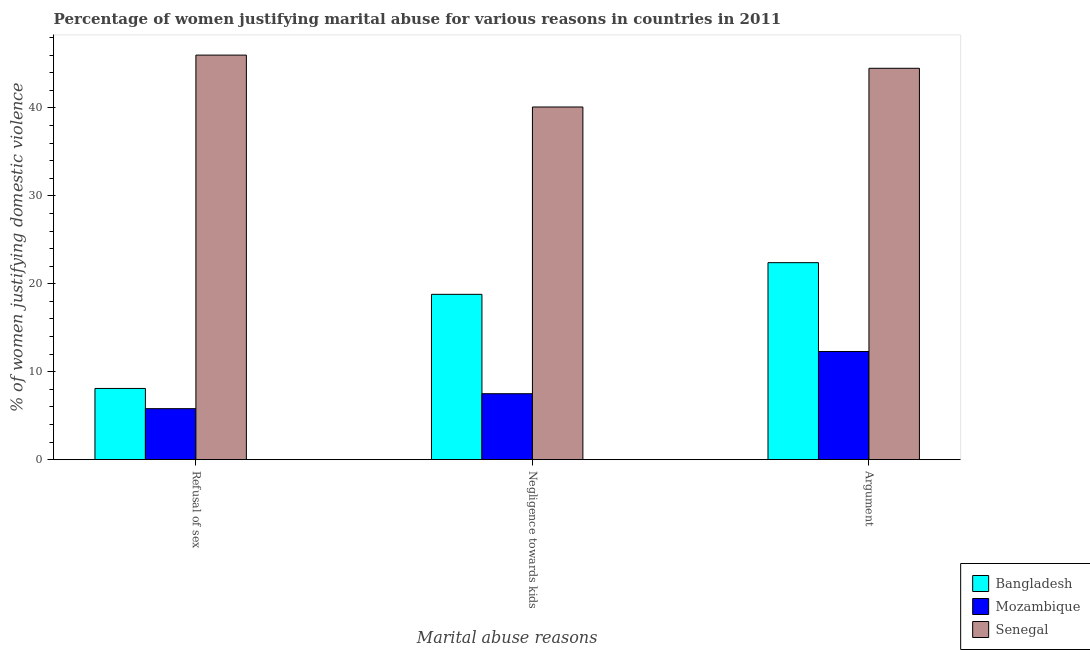How many bars are there on the 3rd tick from the left?
Ensure brevity in your answer.  3. How many bars are there on the 1st tick from the right?
Provide a succinct answer. 3. What is the label of the 1st group of bars from the left?
Offer a very short reply. Refusal of sex. Across all countries, what is the maximum percentage of women justifying domestic violence due to negligence towards kids?
Give a very brief answer. 40.1. Across all countries, what is the minimum percentage of women justifying domestic violence due to arguments?
Make the answer very short. 12.3. In which country was the percentage of women justifying domestic violence due to refusal of sex maximum?
Your response must be concise. Senegal. In which country was the percentage of women justifying domestic violence due to refusal of sex minimum?
Your answer should be very brief. Mozambique. What is the total percentage of women justifying domestic violence due to arguments in the graph?
Provide a succinct answer. 79.2. What is the difference between the percentage of women justifying domestic violence due to refusal of sex in Senegal and that in Mozambique?
Offer a very short reply. 40.2. What is the difference between the percentage of women justifying domestic violence due to refusal of sex in Bangladesh and the percentage of women justifying domestic violence due to arguments in Mozambique?
Keep it short and to the point. -4.2. What is the average percentage of women justifying domestic violence due to refusal of sex per country?
Your answer should be very brief. 19.97. What is the difference between the percentage of women justifying domestic violence due to negligence towards kids and percentage of women justifying domestic violence due to arguments in Bangladesh?
Ensure brevity in your answer.  -3.6. In how many countries, is the percentage of women justifying domestic violence due to refusal of sex greater than 14 %?
Ensure brevity in your answer.  1. What is the ratio of the percentage of women justifying domestic violence due to arguments in Senegal to that in Bangladesh?
Offer a very short reply. 1.99. What is the difference between the highest and the second highest percentage of women justifying domestic violence due to negligence towards kids?
Your response must be concise. 21.3. What is the difference between the highest and the lowest percentage of women justifying domestic violence due to arguments?
Provide a succinct answer. 32.2. What does the 3rd bar from the left in Argument represents?
Keep it short and to the point. Senegal. What does the 1st bar from the right in Negligence towards kids represents?
Provide a short and direct response. Senegal. Is it the case that in every country, the sum of the percentage of women justifying domestic violence due to refusal of sex and percentage of women justifying domestic violence due to negligence towards kids is greater than the percentage of women justifying domestic violence due to arguments?
Make the answer very short. Yes. How many bars are there?
Your answer should be very brief. 9. How many countries are there in the graph?
Provide a short and direct response. 3. What is the difference between two consecutive major ticks on the Y-axis?
Give a very brief answer. 10. Are the values on the major ticks of Y-axis written in scientific E-notation?
Keep it short and to the point. No. Does the graph contain grids?
Your response must be concise. No. What is the title of the graph?
Ensure brevity in your answer.  Percentage of women justifying marital abuse for various reasons in countries in 2011. Does "China" appear as one of the legend labels in the graph?
Make the answer very short. No. What is the label or title of the X-axis?
Provide a short and direct response. Marital abuse reasons. What is the label or title of the Y-axis?
Ensure brevity in your answer.  % of women justifying domestic violence. What is the % of women justifying domestic violence in Mozambique in Refusal of sex?
Offer a very short reply. 5.8. What is the % of women justifying domestic violence of Bangladesh in Negligence towards kids?
Your answer should be very brief. 18.8. What is the % of women justifying domestic violence in Senegal in Negligence towards kids?
Your answer should be very brief. 40.1. What is the % of women justifying domestic violence of Bangladesh in Argument?
Ensure brevity in your answer.  22.4. What is the % of women justifying domestic violence in Mozambique in Argument?
Keep it short and to the point. 12.3. What is the % of women justifying domestic violence in Senegal in Argument?
Ensure brevity in your answer.  44.5. Across all Marital abuse reasons, what is the maximum % of women justifying domestic violence of Bangladesh?
Your answer should be compact. 22.4. Across all Marital abuse reasons, what is the minimum % of women justifying domestic violence of Bangladesh?
Keep it short and to the point. 8.1. Across all Marital abuse reasons, what is the minimum % of women justifying domestic violence of Mozambique?
Give a very brief answer. 5.8. Across all Marital abuse reasons, what is the minimum % of women justifying domestic violence of Senegal?
Keep it short and to the point. 40.1. What is the total % of women justifying domestic violence of Bangladesh in the graph?
Your answer should be very brief. 49.3. What is the total % of women justifying domestic violence in Mozambique in the graph?
Your answer should be compact. 25.6. What is the total % of women justifying domestic violence in Senegal in the graph?
Make the answer very short. 130.6. What is the difference between the % of women justifying domestic violence in Bangladesh in Refusal of sex and that in Negligence towards kids?
Give a very brief answer. -10.7. What is the difference between the % of women justifying domestic violence of Mozambique in Refusal of sex and that in Negligence towards kids?
Your response must be concise. -1.7. What is the difference between the % of women justifying domestic violence in Bangladesh in Refusal of sex and that in Argument?
Ensure brevity in your answer.  -14.3. What is the difference between the % of women justifying domestic violence in Mozambique in Refusal of sex and that in Argument?
Your answer should be very brief. -6.5. What is the difference between the % of women justifying domestic violence of Mozambique in Negligence towards kids and that in Argument?
Ensure brevity in your answer.  -4.8. What is the difference between the % of women justifying domestic violence in Bangladesh in Refusal of sex and the % of women justifying domestic violence in Senegal in Negligence towards kids?
Your response must be concise. -32. What is the difference between the % of women justifying domestic violence of Mozambique in Refusal of sex and the % of women justifying domestic violence of Senegal in Negligence towards kids?
Your response must be concise. -34.3. What is the difference between the % of women justifying domestic violence in Bangladesh in Refusal of sex and the % of women justifying domestic violence in Mozambique in Argument?
Provide a succinct answer. -4.2. What is the difference between the % of women justifying domestic violence of Bangladesh in Refusal of sex and the % of women justifying domestic violence of Senegal in Argument?
Make the answer very short. -36.4. What is the difference between the % of women justifying domestic violence of Mozambique in Refusal of sex and the % of women justifying domestic violence of Senegal in Argument?
Offer a very short reply. -38.7. What is the difference between the % of women justifying domestic violence in Bangladesh in Negligence towards kids and the % of women justifying domestic violence in Mozambique in Argument?
Provide a short and direct response. 6.5. What is the difference between the % of women justifying domestic violence of Bangladesh in Negligence towards kids and the % of women justifying domestic violence of Senegal in Argument?
Your answer should be very brief. -25.7. What is the difference between the % of women justifying domestic violence of Mozambique in Negligence towards kids and the % of women justifying domestic violence of Senegal in Argument?
Your answer should be very brief. -37. What is the average % of women justifying domestic violence of Bangladesh per Marital abuse reasons?
Your response must be concise. 16.43. What is the average % of women justifying domestic violence of Mozambique per Marital abuse reasons?
Your answer should be very brief. 8.53. What is the average % of women justifying domestic violence in Senegal per Marital abuse reasons?
Your answer should be very brief. 43.53. What is the difference between the % of women justifying domestic violence of Bangladesh and % of women justifying domestic violence of Senegal in Refusal of sex?
Your answer should be very brief. -37.9. What is the difference between the % of women justifying domestic violence of Mozambique and % of women justifying domestic violence of Senegal in Refusal of sex?
Give a very brief answer. -40.2. What is the difference between the % of women justifying domestic violence of Bangladesh and % of women justifying domestic violence of Mozambique in Negligence towards kids?
Offer a terse response. 11.3. What is the difference between the % of women justifying domestic violence of Bangladesh and % of women justifying domestic violence of Senegal in Negligence towards kids?
Give a very brief answer. -21.3. What is the difference between the % of women justifying domestic violence of Mozambique and % of women justifying domestic violence of Senegal in Negligence towards kids?
Keep it short and to the point. -32.6. What is the difference between the % of women justifying domestic violence in Bangladesh and % of women justifying domestic violence in Mozambique in Argument?
Offer a very short reply. 10.1. What is the difference between the % of women justifying domestic violence in Bangladesh and % of women justifying domestic violence in Senegal in Argument?
Your answer should be very brief. -22.1. What is the difference between the % of women justifying domestic violence of Mozambique and % of women justifying domestic violence of Senegal in Argument?
Your response must be concise. -32.2. What is the ratio of the % of women justifying domestic violence in Bangladesh in Refusal of sex to that in Negligence towards kids?
Provide a succinct answer. 0.43. What is the ratio of the % of women justifying domestic violence of Mozambique in Refusal of sex to that in Negligence towards kids?
Offer a very short reply. 0.77. What is the ratio of the % of women justifying domestic violence in Senegal in Refusal of sex to that in Negligence towards kids?
Ensure brevity in your answer.  1.15. What is the ratio of the % of women justifying domestic violence in Bangladesh in Refusal of sex to that in Argument?
Your answer should be compact. 0.36. What is the ratio of the % of women justifying domestic violence of Mozambique in Refusal of sex to that in Argument?
Ensure brevity in your answer.  0.47. What is the ratio of the % of women justifying domestic violence of Senegal in Refusal of sex to that in Argument?
Make the answer very short. 1.03. What is the ratio of the % of women justifying domestic violence in Bangladesh in Negligence towards kids to that in Argument?
Provide a succinct answer. 0.84. What is the ratio of the % of women justifying domestic violence in Mozambique in Negligence towards kids to that in Argument?
Offer a very short reply. 0.61. What is the ratio of the % of women justifying domestic violence in Senegal in Negligence towards kids to that in Argument?
Your response must be concise. 0.9. What is the difference between the highest and the second highest % of women justifying domestic violence in Bangladesh?
Provide a succinct answer. 3.6. What is the difference between the highest and the lowest % of women justifying domestic violence of Mozambique?
Ensure brevity in your answer.  6.5. What is the difference between the highest and the lowest % of women justifying domestic violence in Senegal?
Give a very brief answer. 5.9. 